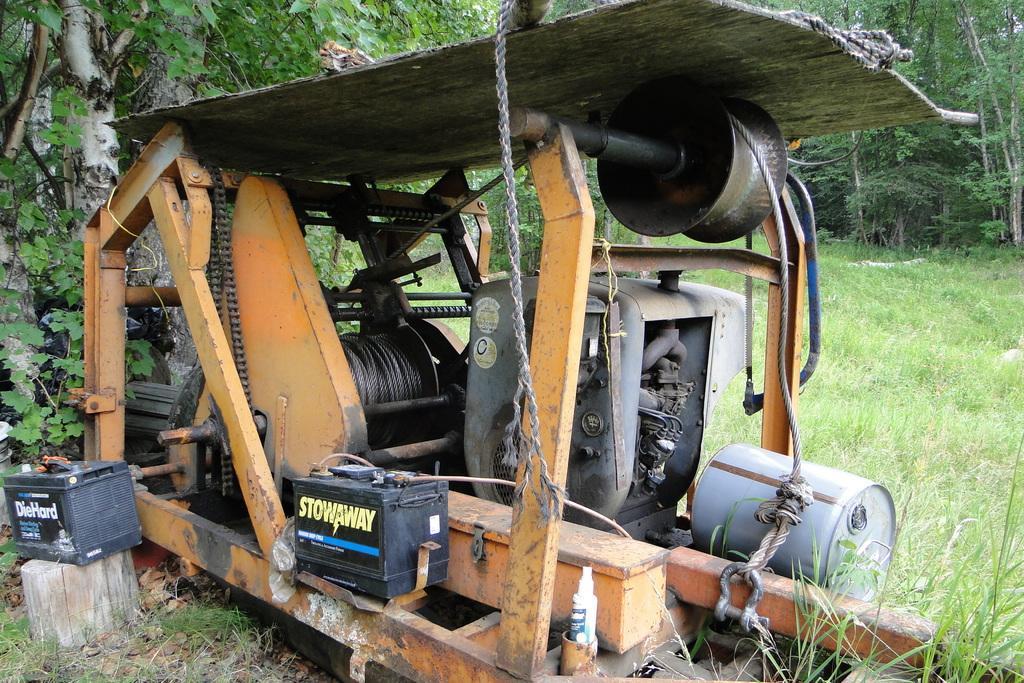How would you summarize this image in a sentence or two? Land is covered with grass. Here we can see a machine. Background there are trees. 